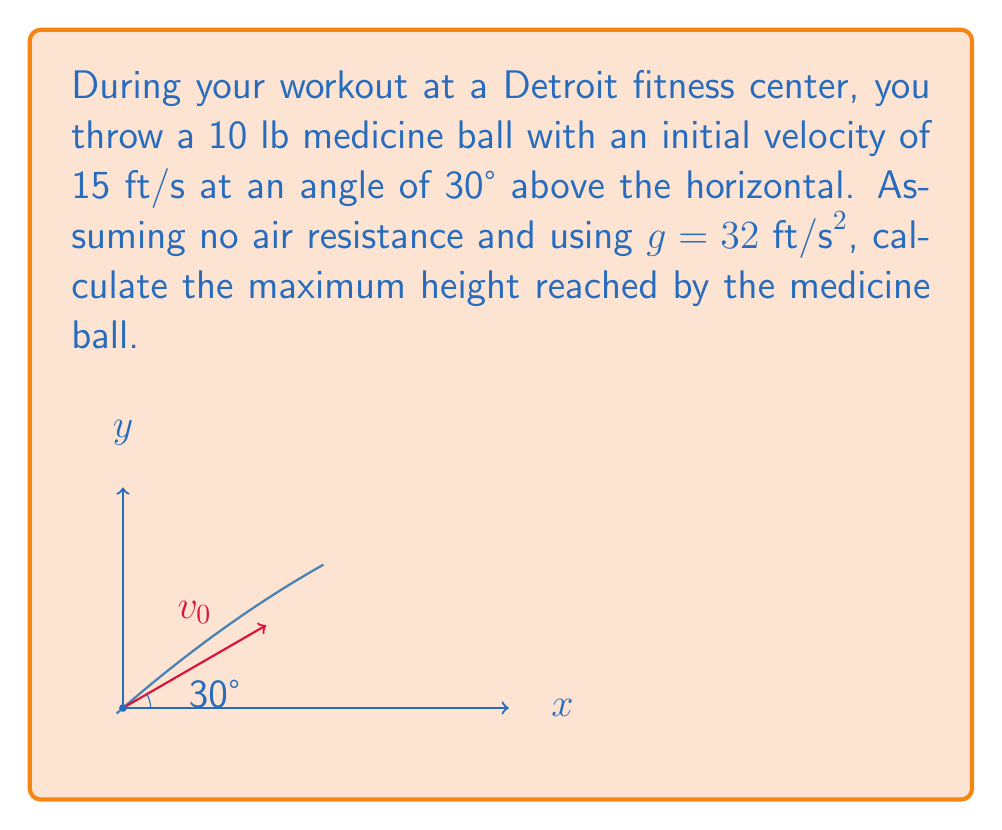Could you help me with this problem? To solve this problem, we'll use the vector-valued function for the trajectory of a projectile and follow these steps:

1) The position vector $\mathbf{r}(t)$ for a projectile launched from the origin is given by:

   $$\mathbf{r}(t) = (v_0 \cos \theta)t\mathbf{i} + (v_0 \sin \theta t - \frac{1}{2}gt^2)\mathbf{j}$$

   where $v_0$ is the initial velocity, $\theta$ is the launch angle, and $g$ is the acceleration due to gravity.

2) We're interested in the maximum height, which occurs when the vertical velocity is zero. The vertical component of velocity is:

   $$v_y(t) = v_0 \sin \theta - gt$$

3) Set this equal to zero and solve for the time at maximum height, $t_{max}$:

   $$0 = v_0 \sin \theta - gt_{max}$$
   $$t_{max} = \frac{v_0 \sin \theta}{g}$$

4) Substitute the given values: $v_0 = 15$ ft/s, $\theta = 30°$, and $g = 32$ ft/s²

   $$t_{max} = \frac{15 \sin 30°}{32} = \frac{15 \cdot 0.5}{32} = \frac{7.5}{32} \approx 0.234375 \text{ s}$$

5) Now, use this time in the vertical component of the position vector to find the maximum height:

   $$y_{max} = v_0 \sin \theta \cdot t_{max} - \frac{1}{2}g(t_{max})^2$$

6) Substitute the values:

   $$y_{max} = 15 \sin 30° \cdot 0.234375 - \frac{1}{2} \cdot 32 \cdot (0.234375)^2$$
   $$y_{max} = 7.5 \cdot 0.234375 - 16 \cdot 0.0549316$$
   $$y_{max} = 1.7578125 - 0.878906$$
   $$y_{max} = 0.878906 \text{ ft}$$

7) Round to two decimal places for the final answer.
Answer: 0.88 ft 